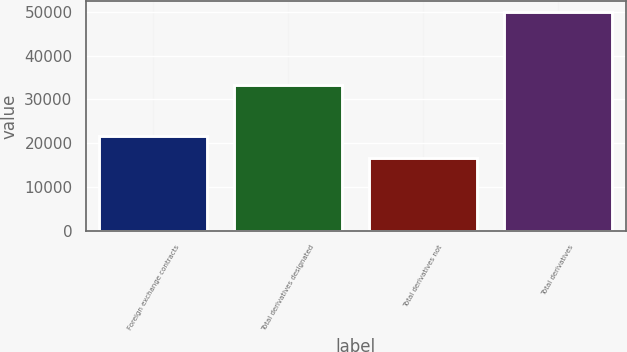Convert chart to OTSL. <chart><loc_0><loc_0><loc_500><loc_500><bar_chart><fcel>Foreign exchange contracts<fcel>Total derivatives designated<fcel>Total derivatives not<fcel>Total derivatives<nl><fcel>21666<fcel>33297<fcel>16604<fcel>49901<nl></chart> 